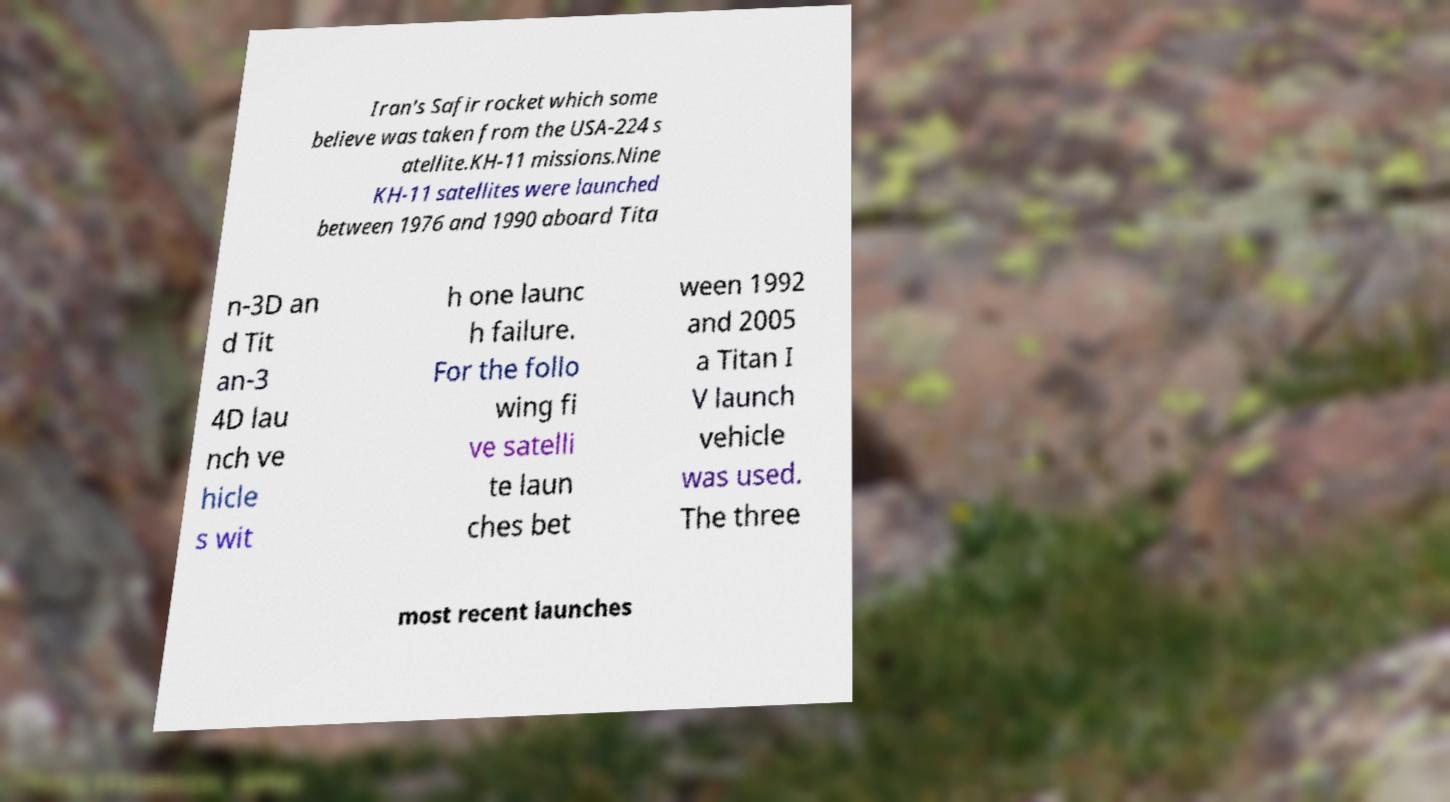Can you accurately transcribe the text from the provided image for me? Iran's Safir rocket which some believe was taken from the USA-224 s atellite.KH-11 missions.Nine KH-11 satellites were launched between 1976 and 1990 aboard Tita n-3D an d Tit an-3 4D lau nch ve hicle s wit h one launc h failure. For the follo wing fi ve satelli te laun ches bet ween 1992 and 2005 a Titan I V launch vehicle was used. The three most recent launches 